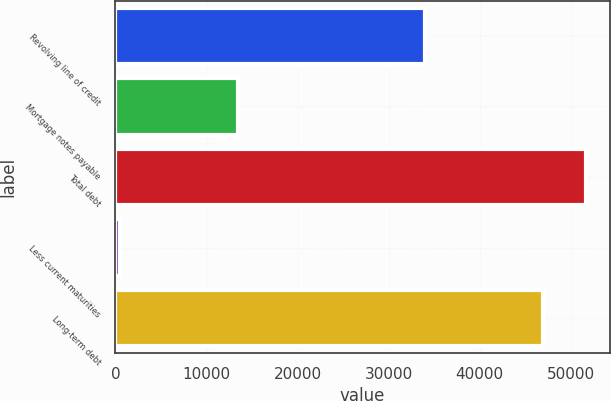Convert chart. <chart><loc_0><loc_0><loc_500><loc_500><bar_chart><fcel>Revolving line of credit<fcel>Mortgage notes payable<fcel>Total debt<fcel>Less current maturities<fcel>Long-term debt<nl><fcel>34000<fcel>13459<fcel>51670.3<fcel>486<fcel>46973<nl></chart> 